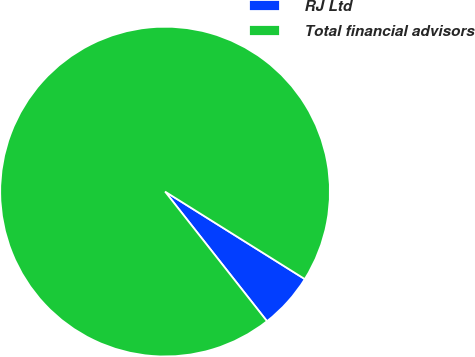Convert chart. <chart><loc_0><loc_0><loc_500><loc_500><pie_chart><fcel>RJ Ltd<fcel>Total financial advisors<nl><fcel>5.49%<fcel>94.51%<nl></chart> 